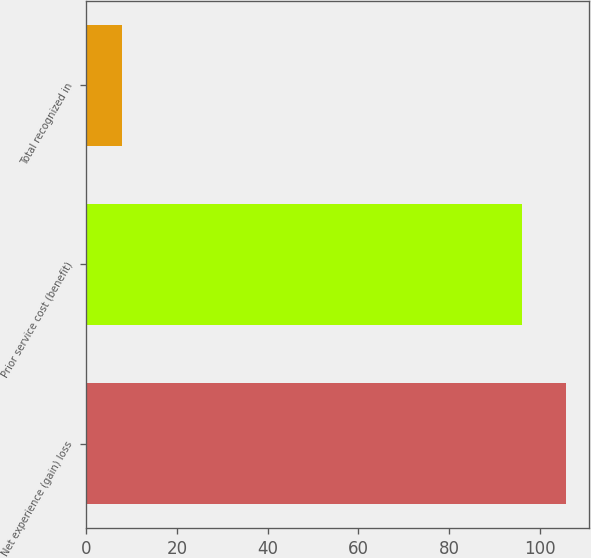Convert chart to OTSL. <chart><loc_0><loc_0><loc_500><loc_500><bar_chart><fcel>Net experience (gain) loss<fcel>Prior service cost (benefit)<fcel>Total recognized in<nl><fcel>105.6<fcel>96<fcel>8<nl></chart> 